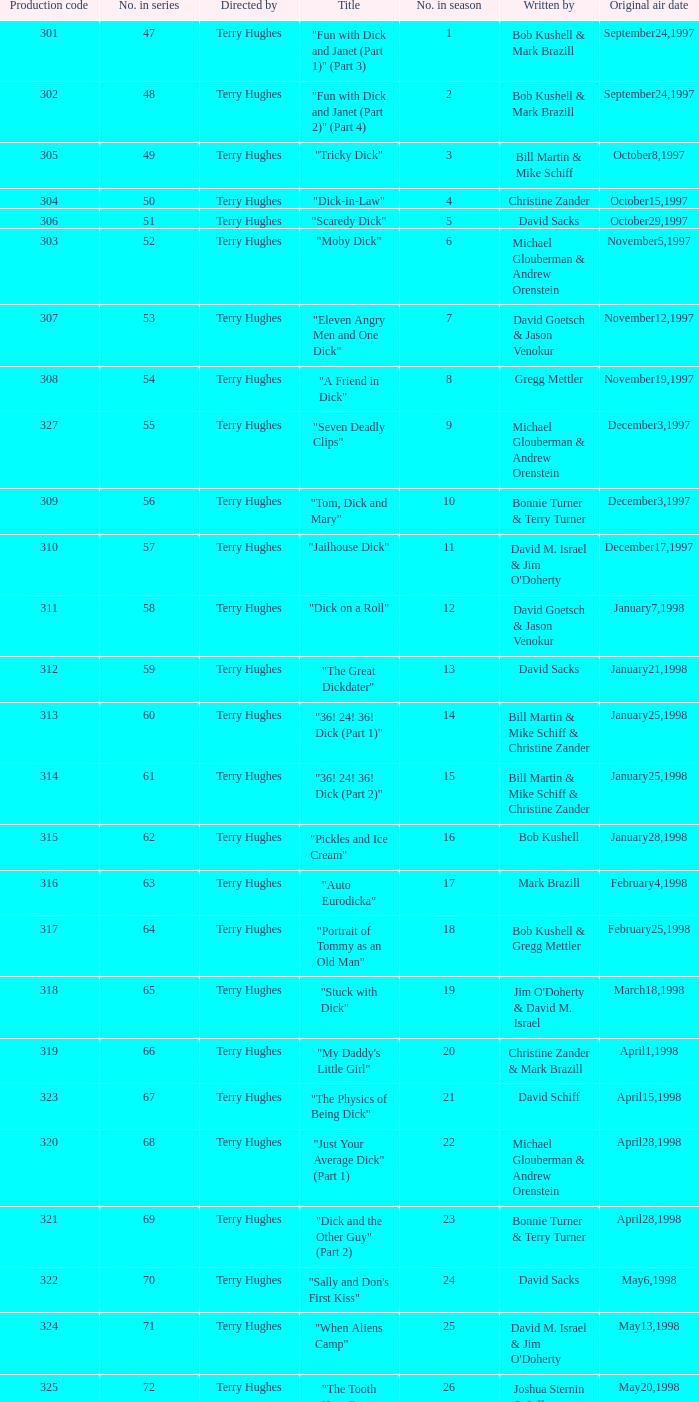Who were the writers of the episode titled "Tricky Dick"? Bill Martin & Mike Schiff. 